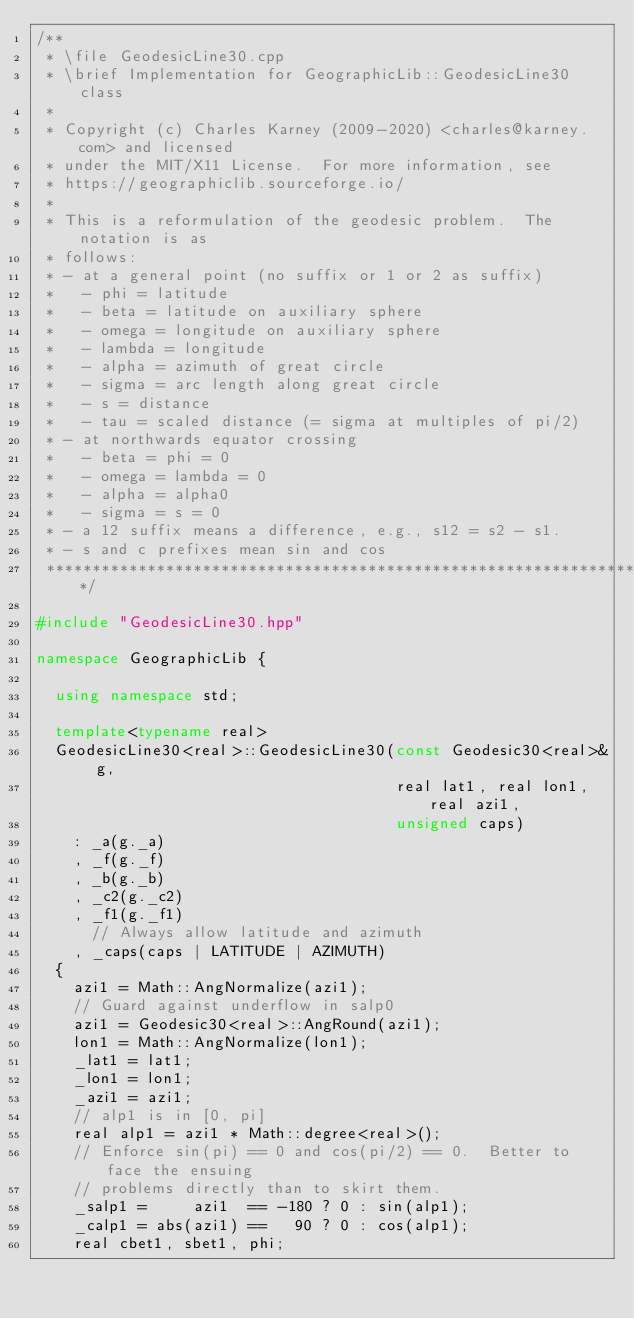Convert code to text. <code><loc_0><loc_0><loc_500><loc_500><_C++_>/**
 * \file GeodesicLine30.cpp
 * \brief Implementation for GeographicLib::GeodesicLine30 class
 *
 * Copyright (c) Charles Karney (2009-2020) <charles@karney.com> and licensed
 * under the MIT/X11 License.  For more information, see
 * https://geographiclib.sourceforge.io/
 *
 * This is a reformulation of the geodesic problem.  The notation is as
 * follows:
 * - at a general point (no suffix or 1 or 2 as suffix)
 *   - phi = latitude
 *   - beta = latitude on auxiliary sphere
 *   - omega = longitude on auxiliary sphere
 *   - lambda = longitude
 *   - alpha = azimuth of great circle
 *   - sigma = arc length along great circle
 *   - s = distance
 *   - tau = scaled distance (= sigma at multiples of pi/2)
 * - at northwards equator crossing
 *   - beta = phi = 0
 *   - omega = lambda = 0
 *   - alpha = alpha0
 *   - sigma = s = 0
 * - a 12 suffix means a difference, e.g., s12 = s2 - s1.
 * - s and c prefixes mean sin and cos
 **********************************************************************/

#include "GeodesicLine30.hpp"

namespace GeographicLib {

  using namespace std;

  template<typename real>
  GeodesicLine30<real>::GeodesicLine30(const Geodesic30<real>& g,
                                       real lat1, real lon1, real azi1,
                                       unsigned caps)
    : _a(g._a)
    , _f(g._f)
    , _b(g._b)
    , _c2(g._c2)
    , _f1(g._f1)
      // Always allow latitude and azimuth
    , _caps(caps | LATITUDE | AZIMUTH)
  {
    azi1 = Math::AngNormalize(azi1);
    // Guard against underflow in salp0
    azi1 = Geodesic30<real>::AngRound(azi1);
    lon1 = Math::AngNormalize(lon1);
    _lat1 = lat1;
    _lon1 = lon1;
    _azi1 = azi1;
    // alp1 is in [0, pi]
    real alp1 = azi1 * Math::degree<real>();
    // Enforce sin(pi) == 0 and cos(pi/2) == 0.  Better to face the ensuing
    // problems directly than to skirt them.
    _salp1 =     azi1  == -180 ? 0 : sin(alp1);
    _calp1 = abs(azi1) ==   90 ? 0 : cos(alp1);
    real cbet1, sbet1, phi;</code> 